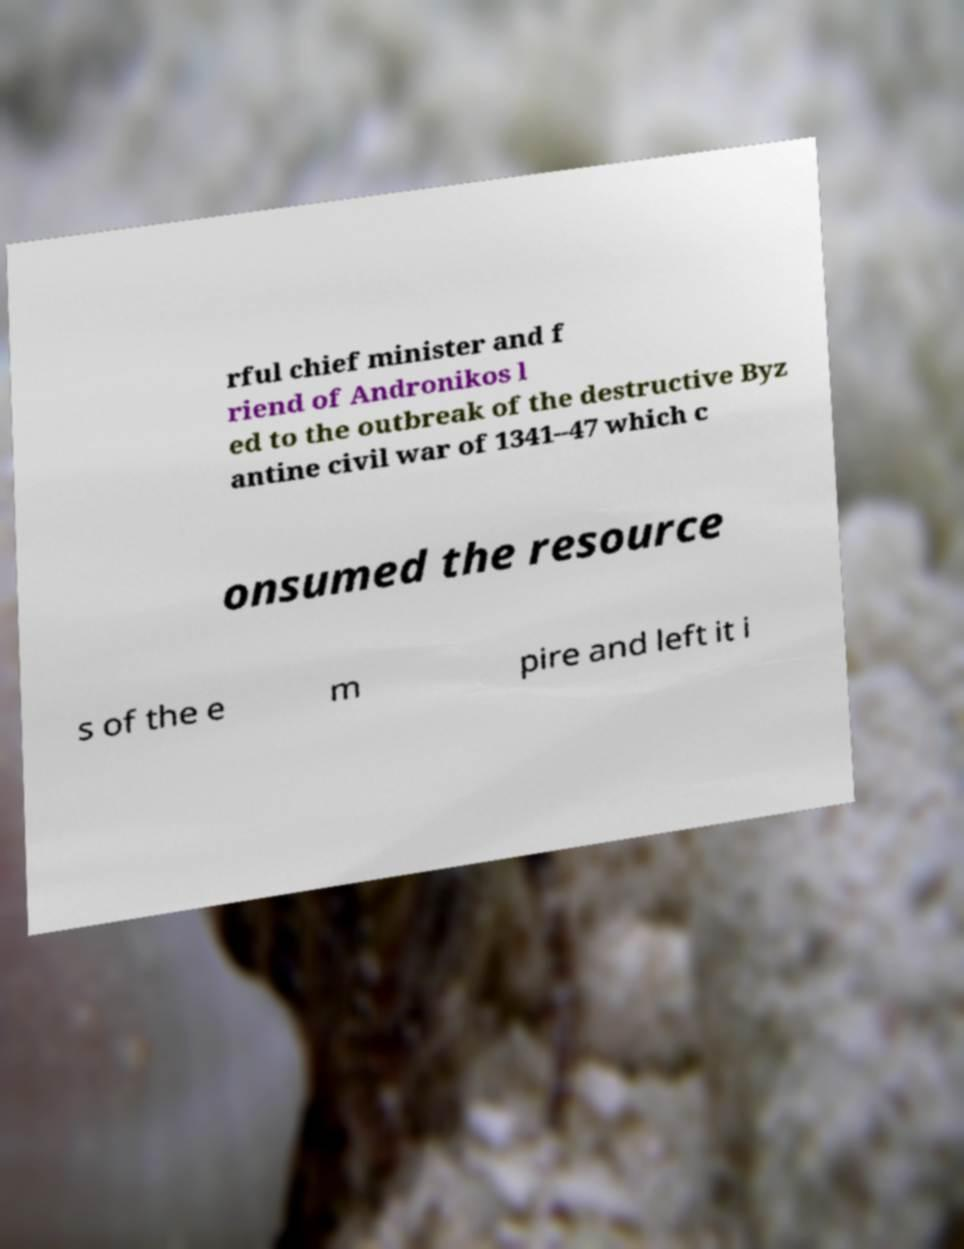Please read and relay the text visible in this image. What does it say? rful chief minister and f riend of Andronikos l ed to the outbreak of the destructive Byz antine civil war of 1341–47 which c onsumed the resource s of the e m pire and left it i 